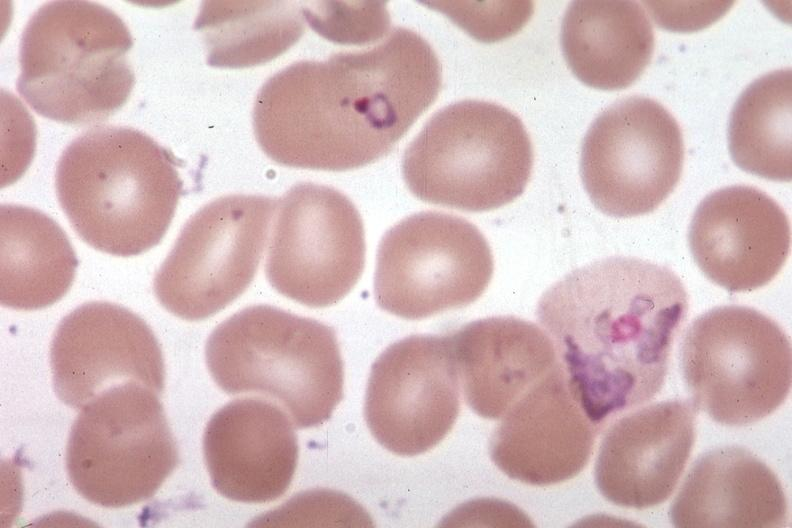s polycystic disease present?
Answer the question using a single word or phrase. No 